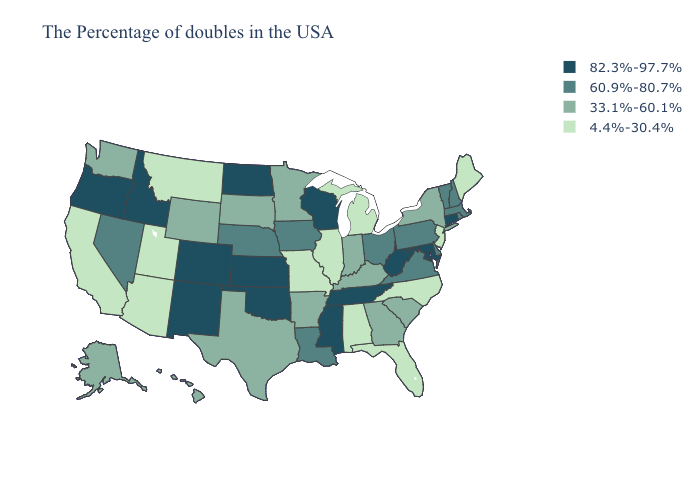Which states have the lowest value in the MidWest?
Keep it brief. Michigan, Illinois, Missouri. What is the value of Michigan?
Quick response, please. 4.4%-30.4%. Among the states that border Tennessee , does Mississippi have the lowest value?
Be succinct. No. What is the lowest value in the USA?
Keep it brief. 4.4%-30.4%. Name the states that have a value in the range 33.1%-60.1%?
Be succinct. New York, South Carolina, Georgia, Kentucky, Indiana, Arkansas, Minnesota, Texas, South Dakota, Wyoming, Washington, Alaska, Hawaii. What is the lowest value in the USA?
Keep it brief. 4.4%-30.4%. What is the value of Wisconsin?
Quick response, please. 82.3%-97.7%. Does Montana have the lowest value in the USA?
Keep it brief. Yes. Name the states that have a value in the range 60.9%-80.7%?
Write a very short answer. Massachusetts, Rhode Island, New Hampshire, Vermont, Delaware, Pennsylvania, Virginia, Ohio, Louisiana, Iowa, Nebraska, Nevada. Which states have the lowest value in the South?
Give a very brief answer. North Carolina, Florida, Alabama. Does the map have missing data?
Give a very brief answer. No. Name the states that have a value in the range 82.3%-97.7%?
Keep it brief. Connecticut, Maryland, West Virginia, Tennessee, Wisconsin, Mississippi, Kansas, Oklahoma, North Dakota, Colorado, New Mexico, Idaho, Oregon. Does Louisiana have a higher value than Connecticut?
Write a very short answer. No. What is the lowest value in the Northeast?
Keep it brief. 4.4%-30.4%. Name the states that have a value in the range 4.4%-30.4%?
Keep it brief. Maine, New Jersey, North Carolina, Florida, Michigan, Alabama, Illinois, Missouri, Utah, Montana, Arizona, California. 